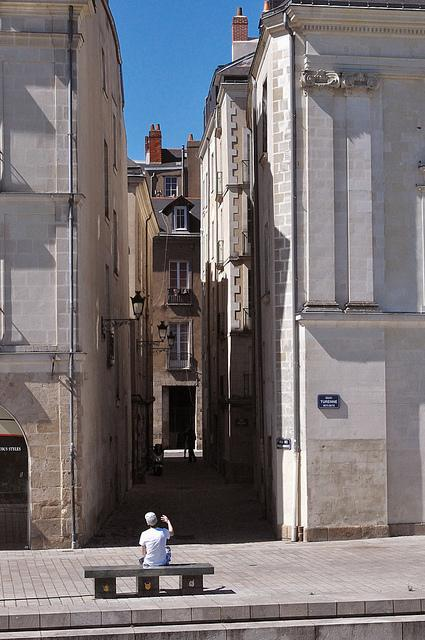Why does the man seated have his arm up? meditation 